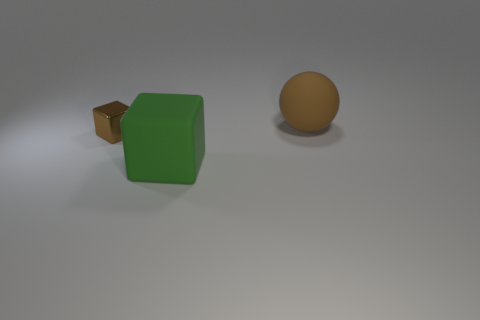Are there any cubes that have the same size as the brown matte object?
Your response must be concise. Yes. Is there a large matte ball on the left side of the large sphere that is behind the tiny brown object?
Your answer should be compact. No. How many cylinders are either big brown rubber things or small brown metallic objects?
Provide a succinct answer. 0. Are there any other metal things that have the same shape as the tiny brown metallic thing?
Ensure brevity in your answer.  No. The small metal thing is what shape?
Ensure brevity in your answer.  Cube. How many objects are either cyan cylinders or large matte balls?
Provide a succinct answer. 1. Do the block on the left side of the big green matte thing and the brown thing that is to the right of the large block have the same size?
Give a very brief answer. No. What number of other things are there of the same material as the large sphere
Your answer should be very brief. 1. Is the number of large rubber spheres to the left of the brown shiny block greater than the number of metal cubes that are in front of the large rubber block?
Offer a terse response. No. There is a thing in front of the shiny cube; what is it made of?
Ensure brevity in your answer.  Rubber. 